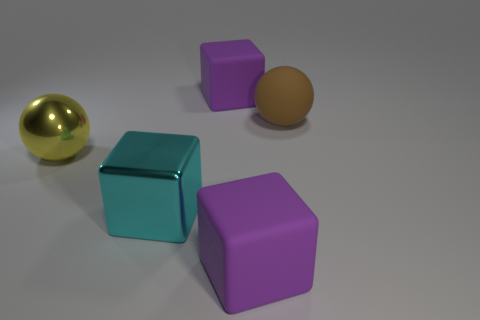There is a purple matte thing on the right side of the big cube behind the large sphere to the left of the cyan cube; what size is it?
Ensure brevity in your answer.  Large. Does the yellow object have the same shape as the large matte thing in front of the big metallic cube?
Provide a succinct answer. No. Is there a small matte object that has the same color as the large matte sphere?
Keep it short and to the point. No. What number of balls are large cyan objects or big metallic objects?
Your response must be concise. 1. Is there another big brown matte object of the same shape as the large brown rubber object?
Ensure brevity in your answer.  No. How many other objects are there of the same color as the metal cube?
Provide a short and direct response. 0. Are there fewer matte blocks that are in front of the large cyan block than big brown objects?
Provide a short and direct response. No. What number of brown rubber spheres are there?
Your answer should be compact. 1. What number of big cyan things are made of the same material as the brown sphere?
Provide a short and direct response. 0. How many objects are big purple cubes that are behind the big brown thing or brown rubber cylinders?
Your response must be concise. 1. 